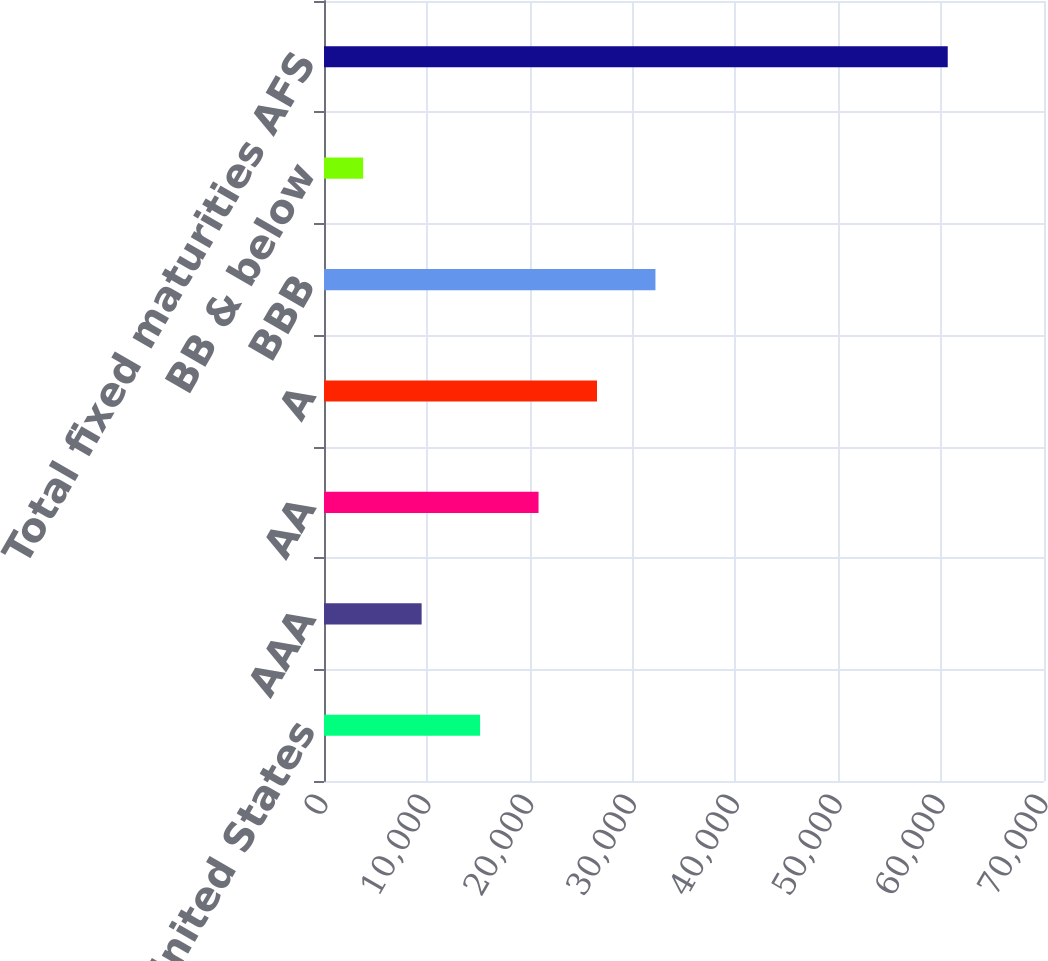<chart> <loc_0><loc_0><loc_500><loc_500><bar_chart><fcel>United States<fcel>AAA<fcel>AA<fcel>A<fcel>BBB<fcel>BB & below<fcel>Total fixed maturities AFS<nl><fcel>15175.4<fcel>9492.2<fcel>20858.6<fcel>26541.8<fcel>32225<fcel>3809<fcel>60641<nl></chart> 